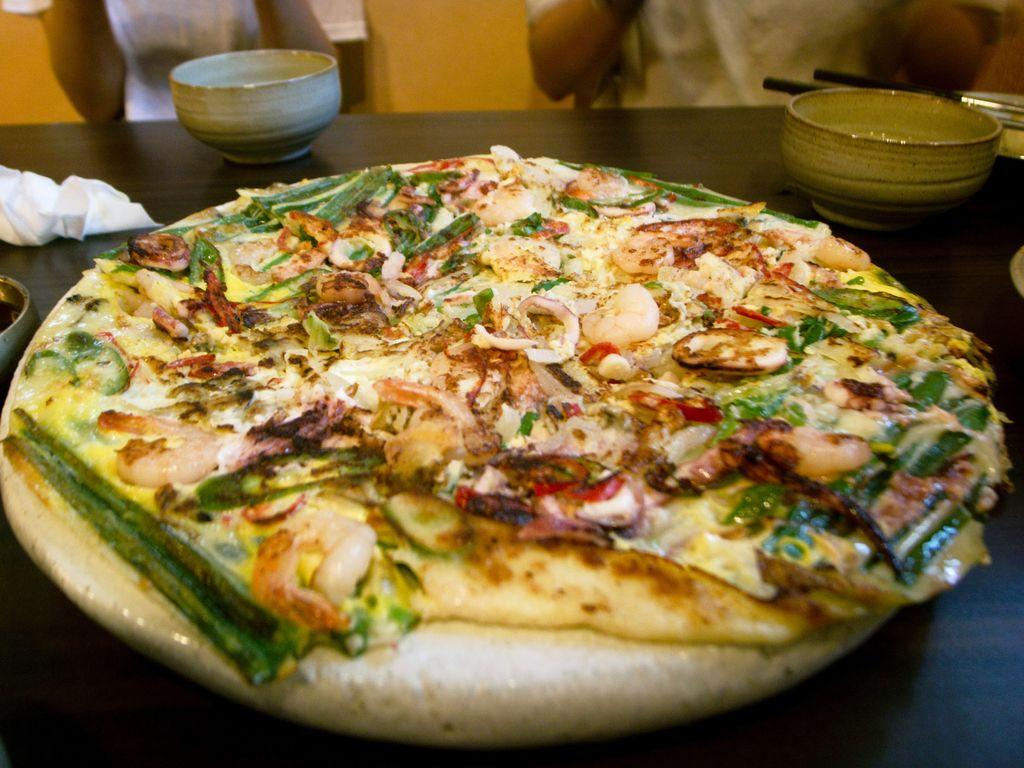What type of food item is visible in the image? There is a food item in the image, but the specific type cannot be determined from the provided facts. How many bowls are present in the image? There are two bowls in the image. What else can be seen on the table besides the bowls? There are other objects on the table, but their specific nature cannot be determined from the provided facts. How many people are in front of the table? There are two persons in front of the table. What type of nut is being cracked by the person on the left in the image? There is no nut or person visible in the image; it only mentions the presence of a food item, two bowls, other objects on the table, and two persons in front of the table. 